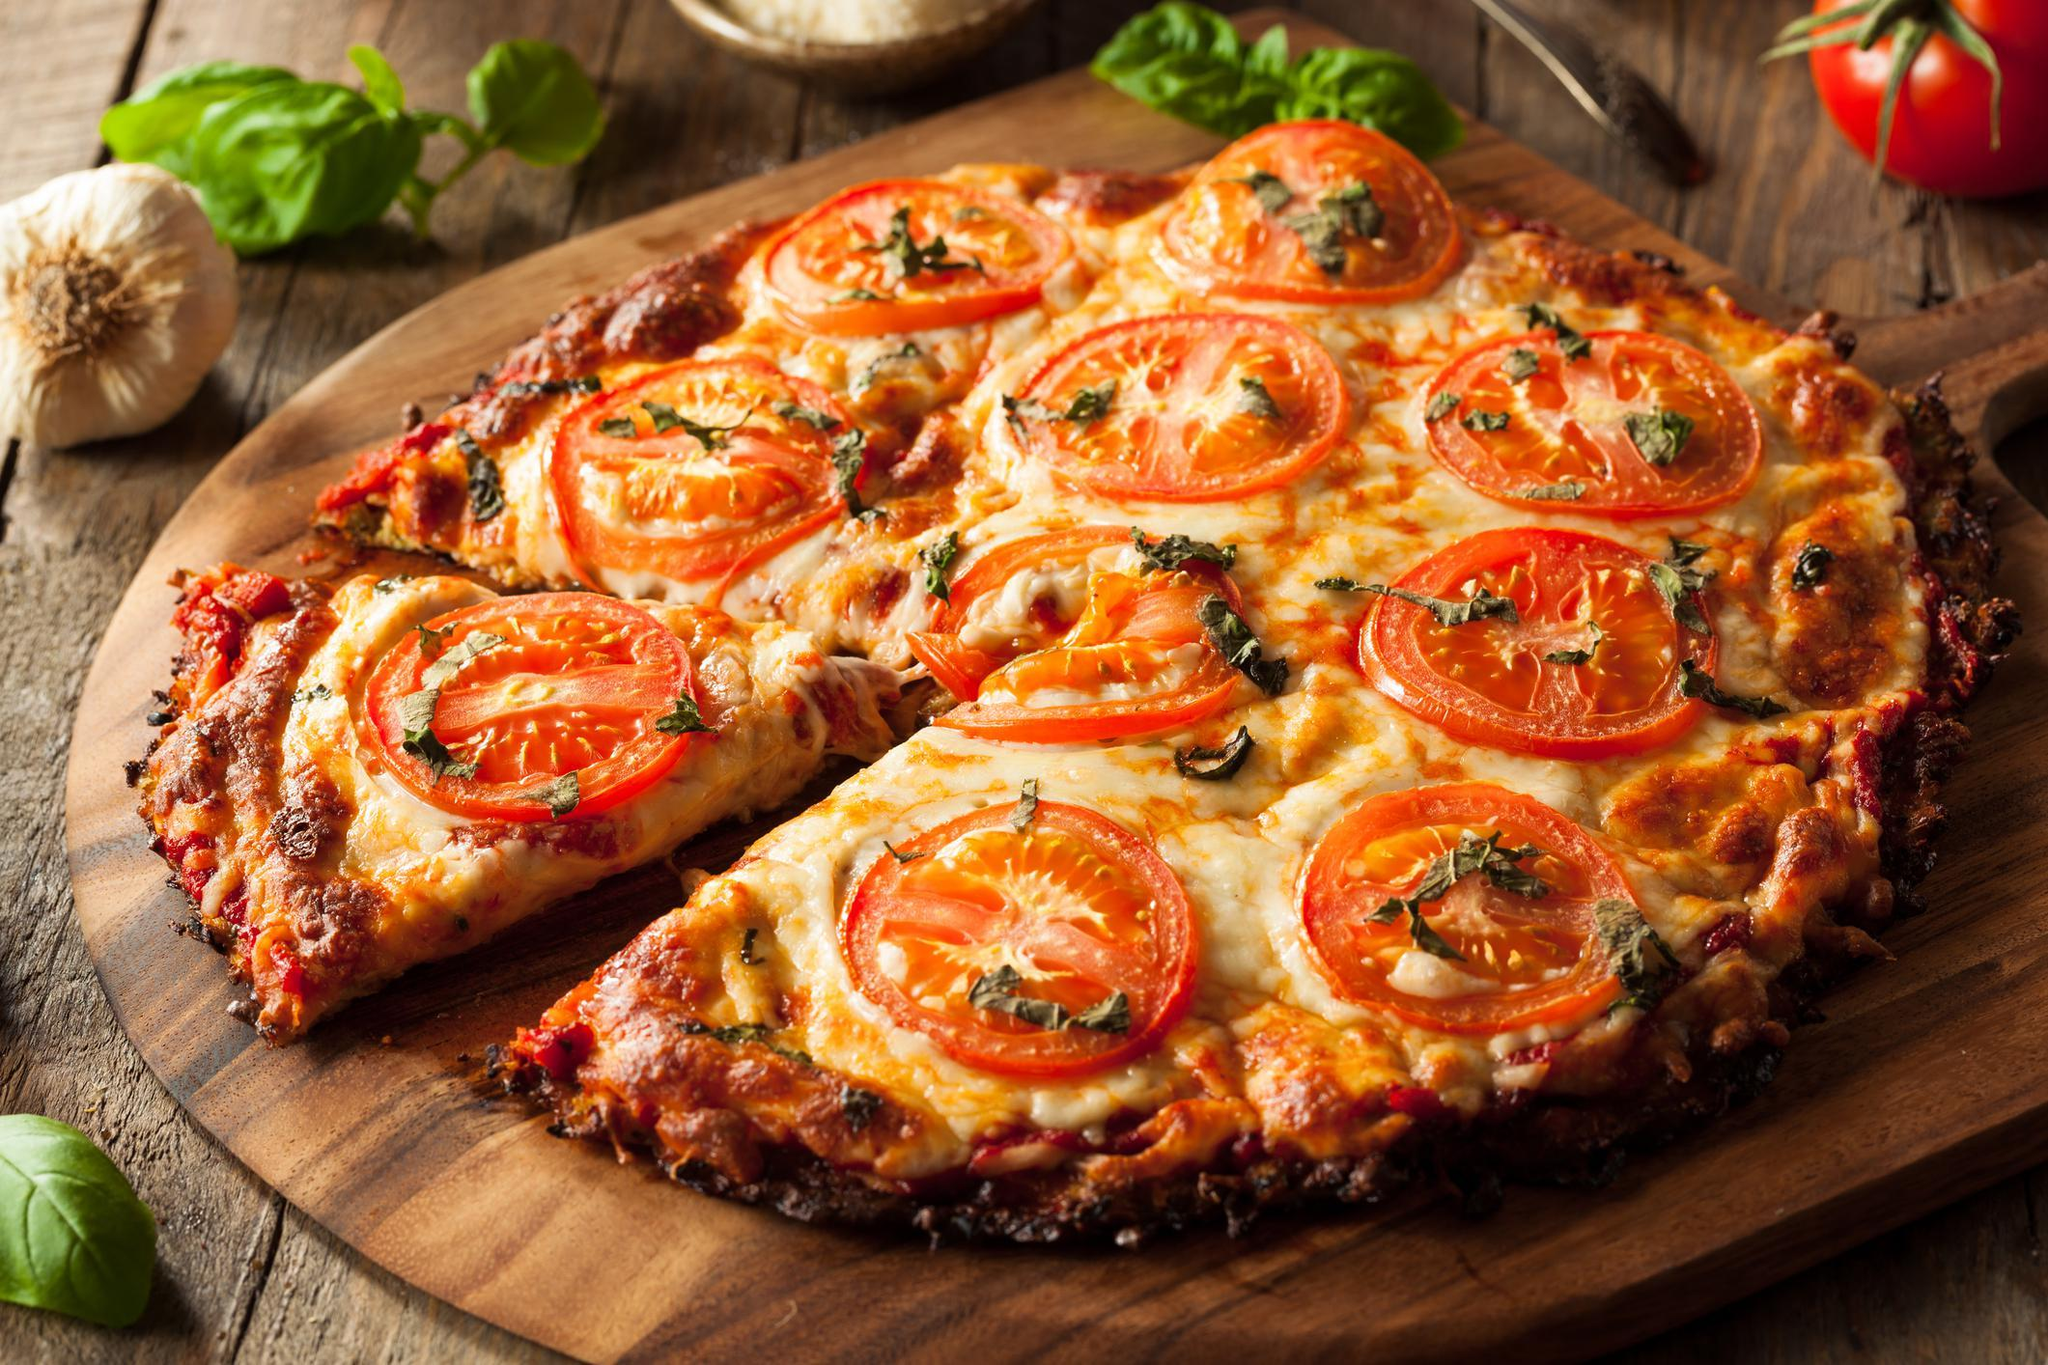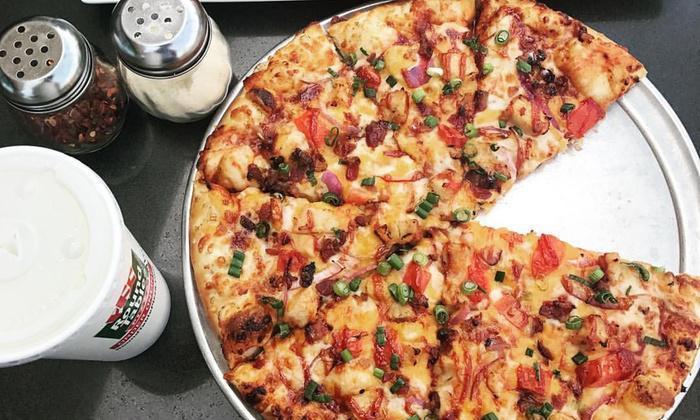The first image is the image on the left, the second image is the image on the right. Analyze the images presented: Is the assertion "There is a pizza with exactly one missing slice." valid? Answer yes or no. Yes. The first image is the image on the left, the second image is the image on the right. Analyze the images presented: Is the assertion "There's a whole head of garlic and at least one tomato next to the pizza in one of the pictures." valid? Answer yes or no. Yes. 